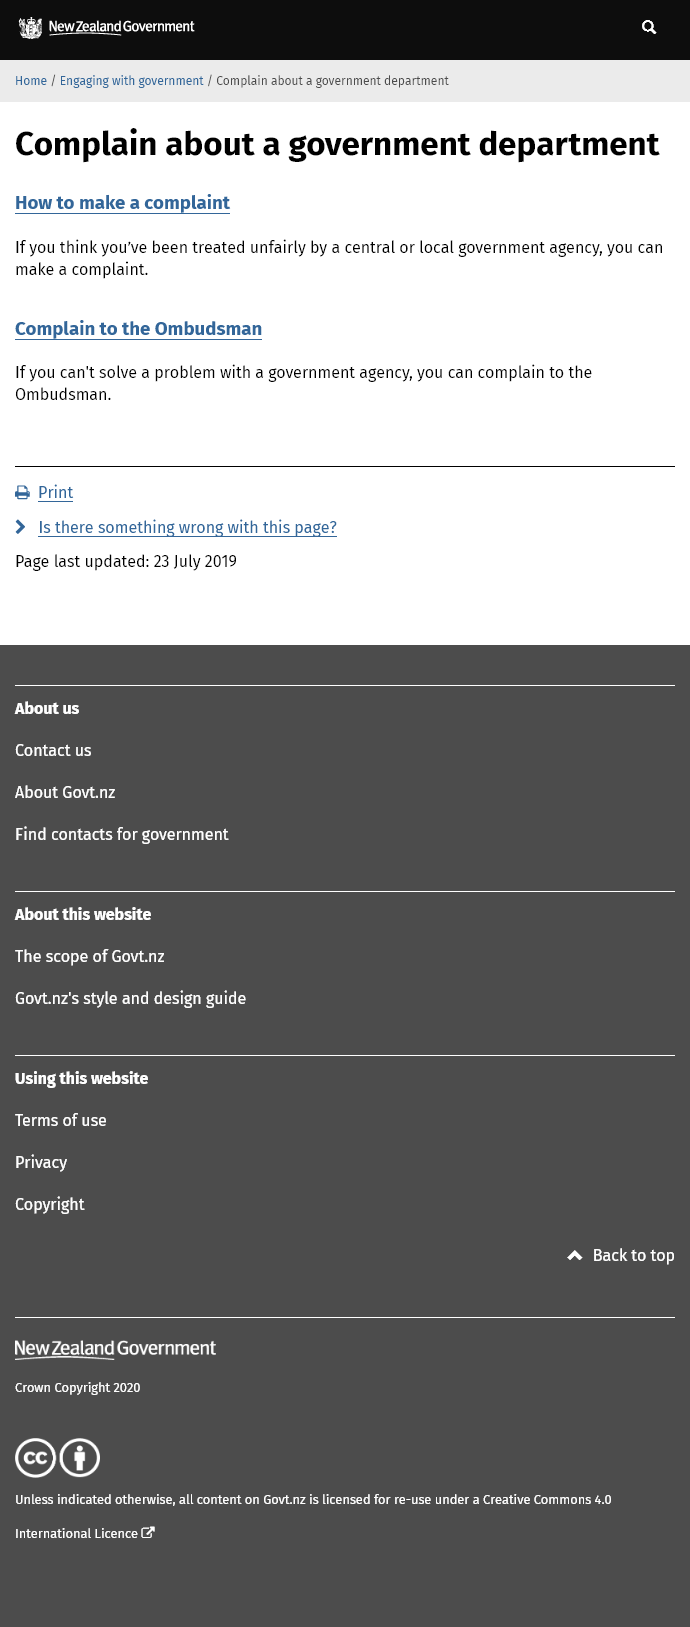Identify some key points in this picture. Yes, you can make a complaint if you think you've been treated unfairly. The fact that one would complain to the ombudsman if they complain about a government department suggests that they would be complaining about the actions or inactions of that department, rather than the department itself. Yes, you can complain to the ombudsman. 